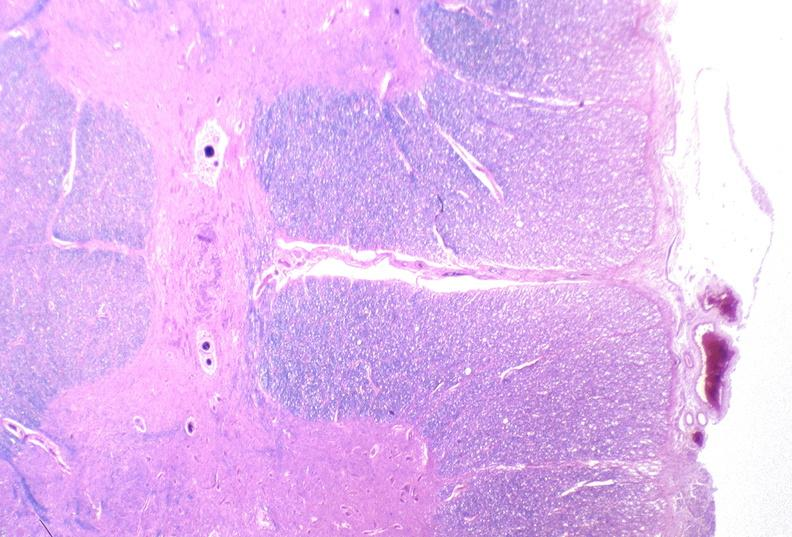s stillborn cord around neck present?
Answer the question using a single word or phrase. No 